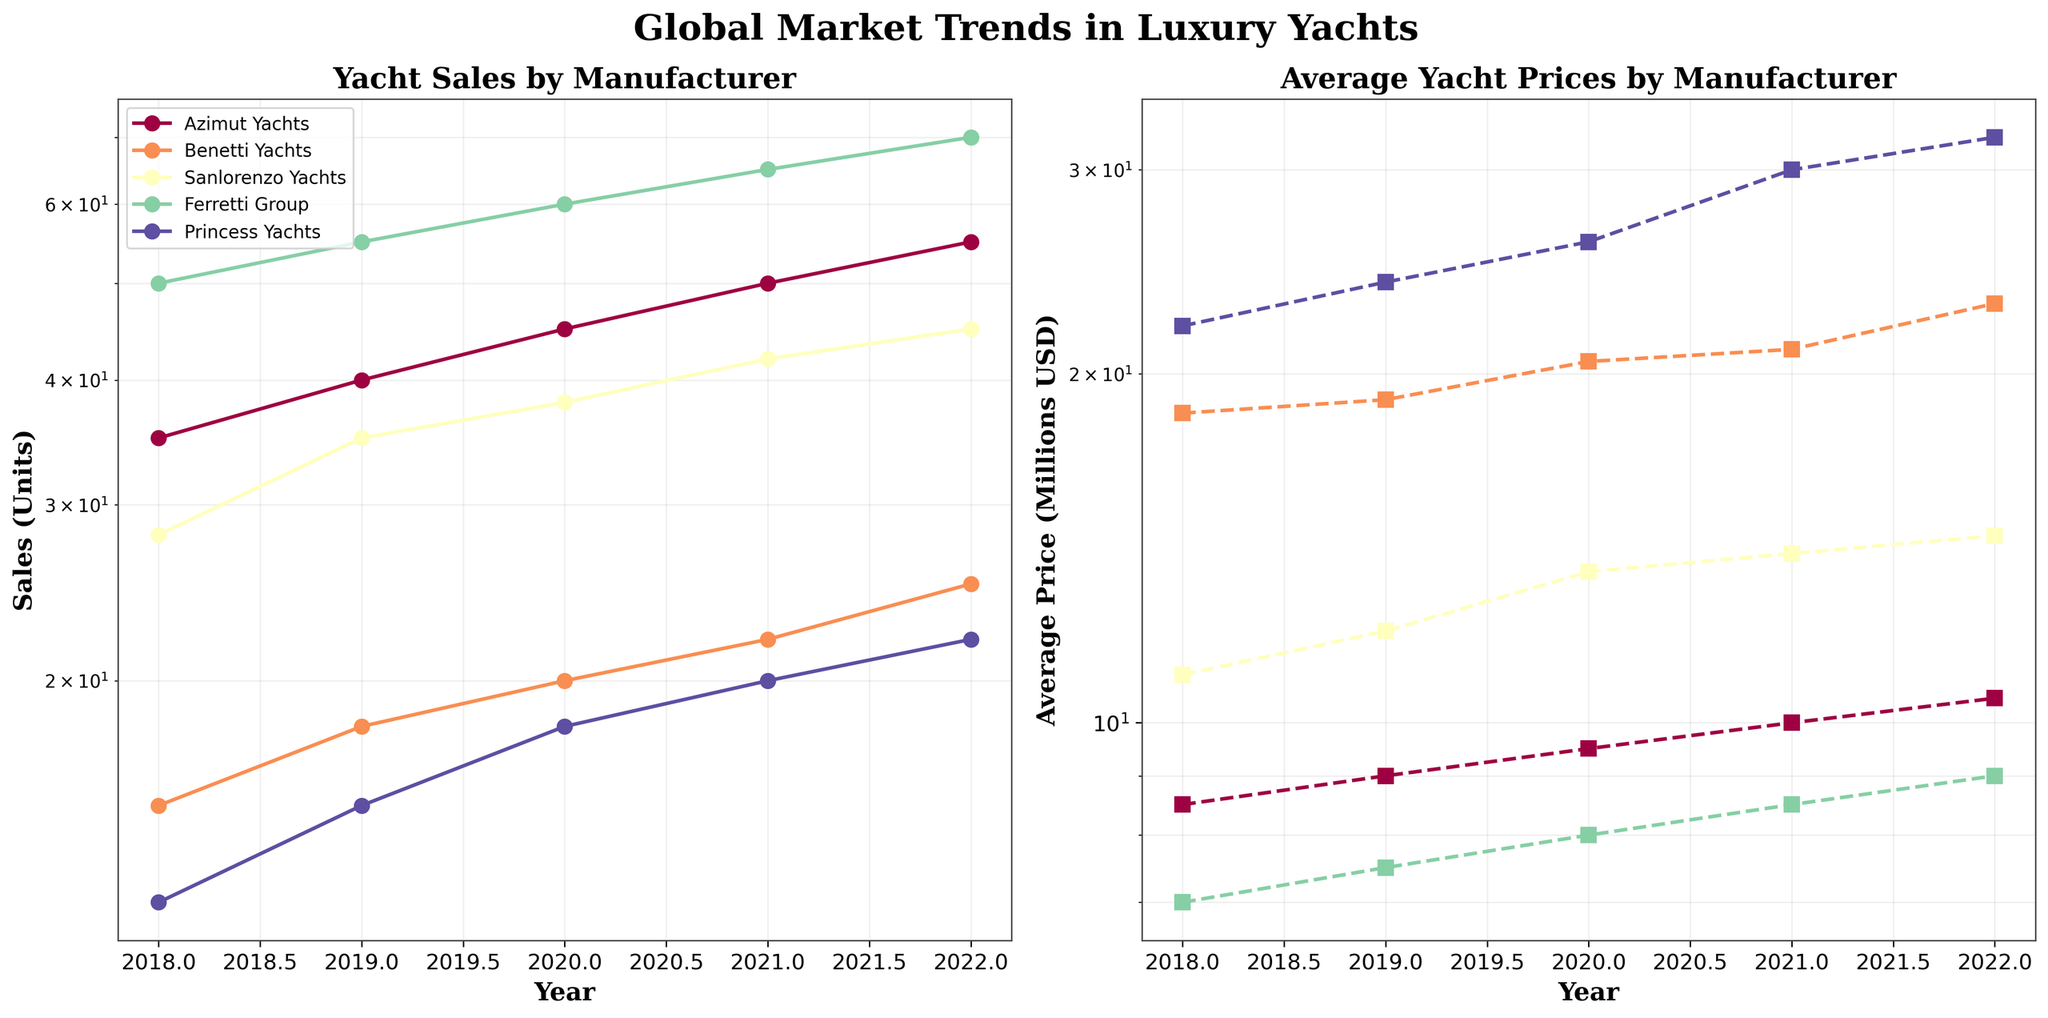What is the title of the figure? The title of the figure is located at the top-center and uses a combination of large, bold, and serif fonts for emphasis. Therefore, to determine the title, look at the top of the figure where the text is prominently displayed.
Answer: Global Market Trends in Luxury Yachts How many manufacturers are represented in the data? The figure legend on the first subplot (Yacht Sales by Manufacturer) shows different color lines for each manufacturer. Count the distinct colored lines in the legend to determine the number of manufacturers.
Answer: 5 Which manufacturer had the highest yacht sales in 2022? In the first subplot (Yacht Sales by Manufacturer), look for the year 2022 on the x-axis and find the highest y-value (log scale of sales units). Trace this value back to the legend to determine the manufacturer.
Answer: Ferretti Group Which manufacturer shows the steepest increase in average price from 2020 to 2022? On the second subplot (Average Yacht Prices by Manufacturer), compare the slopes of the lines for each manufacturer between the years 2020 and 2022. The steepest line indicates the manufacturer with the steepest price increase.
Answer: Princess Yachts What is the trend in yacht sales for Azimut Yachts between 2018 and 2022? Observing the first subplot, track the line that represents Azimut Yachts from 2018 to 2022 and describe how its y-values (sales units) change over these years.
Answer: Increasing Which two manufacturers have the closest average yacht prices in 2021? On the second subplot, locate the year 2021 on the x-axis. Compare the y-values (log scale of price) of each manufacturer's line and identify the two closest values.
Answer: Sanlorenzo Yachts and Azimut Yachts What is the average price increase for Benetti Yachts from 2018 to 2022? On the second subplot, find the y-values for Benetti Yachts in 2018 and 2022, then calculate the difference and average it over the years.
Answer: \( (23.0 - 18.5) / 4 = 1.125 \) million USD per year Which manufacturer had consistent sales growth every year from 2018 to 2022? In the first subplot, look for a line that shows continuous upward movement (no drops) from 2018 to 2022. Identify the corresponding manufacturer from the legend.
Answer: Azimut Yachts In which year did Sanlorenzo Yachts see a significant jump in sales? Observing the first subplot, find the line for Sanlorenzo Yachts and look for the year where there's a notable sharp increase in its y-value (sales).
Answer: 2019 By how much did the average price of yachts for Princess Yachts increase from 2021 to 2022? In the second subplot, find the y-values for Princess Yachts in 2021 and 2022, then calculate the difference between these values.
Answer: \( 32.0 - 30.0 = 2.0 \) million USD 